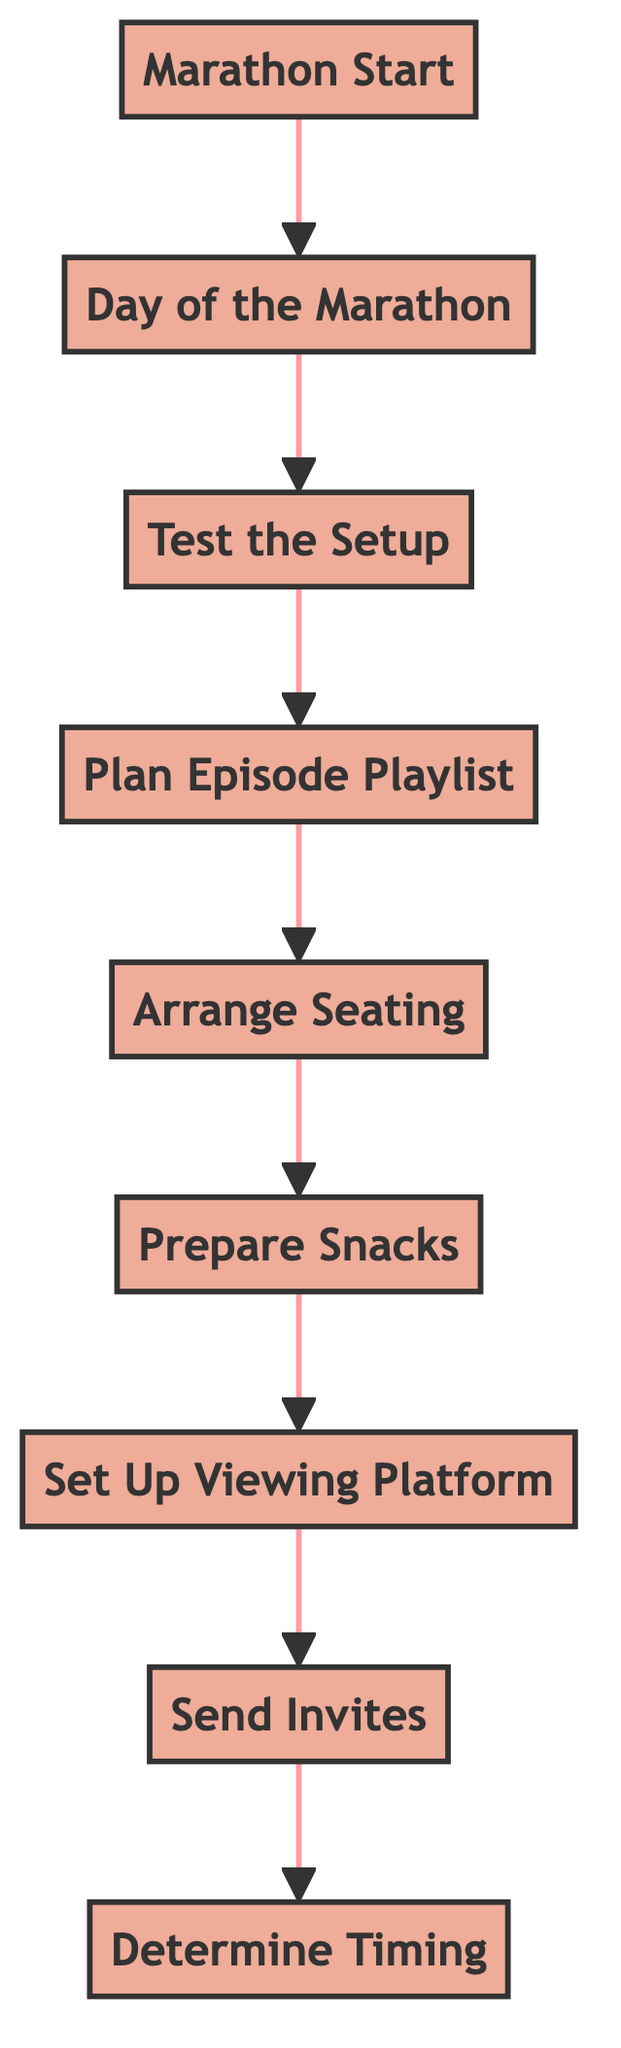What is the last step before the marathon begins? The last step before the marathon starts is the "Day of the Marathon." This step is directly connected to the "Marathon Start" step in the diagram.
Answer: Day of the Marathon How many total steps are in the diagram? There are nine steps listed in the diagram: Marathon Start, Day of the Marathon, Test the Setup, Plan Episode Playlist, Arrange Seating, Prepare Snacks, Set Up Viewing Platform, Send Invites, and Determine Timing.
Answer: Nine What is the relationship between "Sending Invites" and "Setting Up the Viewing Platform"? "Sending Invites" occurs before "Setting Up the Viewing Platform" in the flowchart, indicating that you should send invites before preparing the viewing area for the marathon.
Answer: Sending Invites comes before Setting Up Viewing Platform What is the first step of the marathon planning process? The first step in the flow from the bottom to the top of the diagram is "Determine Timing." This is the initial action to be taken to plan the marathon.
Answer: Determine Timing Which step follows "Prepare Snacks"? Following "Prepare Snacks," the next step in the flowchart is "Set Up Viewing Platform." This indicates that once snacks are prepared, the next action is to get the viewing area ready.
Answer: Set Up Viewing Platform Which step is dependent on "Testing the Setup"? The step that follows "Testing the Setup" is "Plan Episode Playlist," showing that planning the episode playlist relies on ensuring everything is set up correctly for the viewing.
Answer: Plan Episode Playlist What action must be taken after arranging seating? After arranging seating, the next action is to prepare snacks, indicating that seating arrangements are made before focusing on food.
Answer: Prepare Snacks What is the overall goal of the flowchart? The overall goal of the flowchart is to successfully plan and execute a Friends marathon weekend with friends, following through each necessary step in a sequential manner.
Answer: Plan a Friends Marathon Weekend Which step comes directly after "Send Invites"? The step that comes directly after "Send Invites" is "Set Up Viewing Platform," indicating that once invites are sent, attention should shift to preparing the viewing area.
Answer: Set Up Viewing Platform 